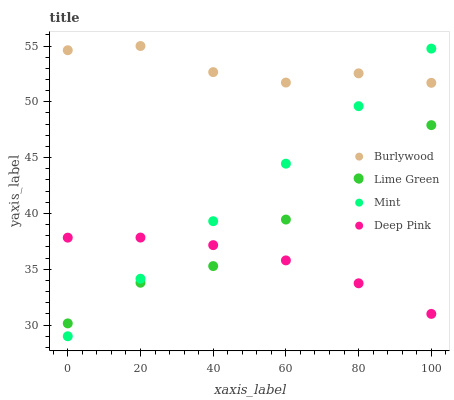Does Deep Pink have the minimum area under the curve?
Answer yes or no. Yes. Does Burlywood have the maximum area under the curve?
Answer yes or no. Yes. Does Mint have the minimum area under the curve?
Answer yes or no. No. Does Mint have the maximum area under the curve?
Answer yes or no. No. Is Mint the smoothest?
Answer yes or no. Yes. Is Burlywood the roughest?
Answer yes or no. Yes. Is Deep Pink the smoothest?
Answer yes or no. No. Is Deep Pink the roughest?
Answer yes or no. No. Does Mint have the lowest value?
Answer yes or no. Yes. Does Deep Pink have the lowest value?
Answer yes or no. No. Does Burlywood have the highest value?
Answer yes or no. Yes. Does Mint have the highest value?
Answer yes or no. No. Is Lime Green less than Burlywood?
Answer yes or no. Yes. Is Burlywood greater than Deep Pink?
Answer yes or no. Yes. Does Deep Pink intersect Mint?
Answer yes or no. Yes. Is Deep Pink less than Mint?
Answer yes or no. No. Is Deep Pink greater than Mint?
Answer yes or no. No. Does Lime Green intersect Burlywood?
Answer yes or no. No. 